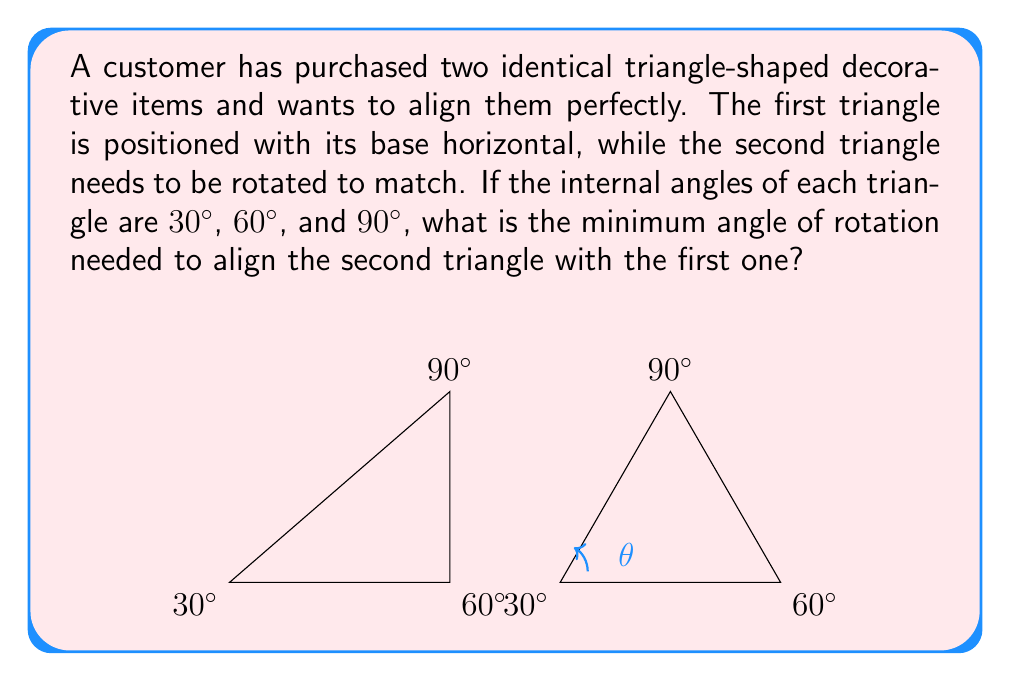Could you help me with this problem? To solve this problem, let's follow these steps:

1) First, we need to identify the current orientation of both triangles:
   - The first triangle is positioned with its base (the side opposite to the 90° angle) horizontal.
   - The second triangle is also positioned with its base horizontal.

2) To align the triangles, we need to rotate the second triangle so that its 90° angle is at the top, just like the first triangle.

3) The angle of rotation needed is the angle between the current position of the 90° angle and its final position:
   - In the current position, the 90° angle is at the bottom right corner of the triangle.
   - In the final position, it needs to be at the top corner.

4) The angle between these two positions is the same as the angle between the base and the hypotenuse of the triangle.

5) In a 30-60-90 triangle, the angles are arranged as follows:
   - The 30° angle is opposite the shorter leg.
   - The 60° angle is opposite the longer leg.
   - The 90° angle is opposite the hypotenuse.

6) The angle we're looking for is the one between the hypotenuse and the longer leg, which is 30°.

7) However, we need to rotate the triangle clockwise, which means we need to use the complementary angle to 30°:

   $$90° - 30° = 60°$$

Therefore, the minimum angle of rotation needed is 60° clockwise.
Answer: 60° 